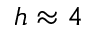Convert formula to latex. <formula><loc_0><loc_0><loc_500><loc_500>h \approx 4</formula> 